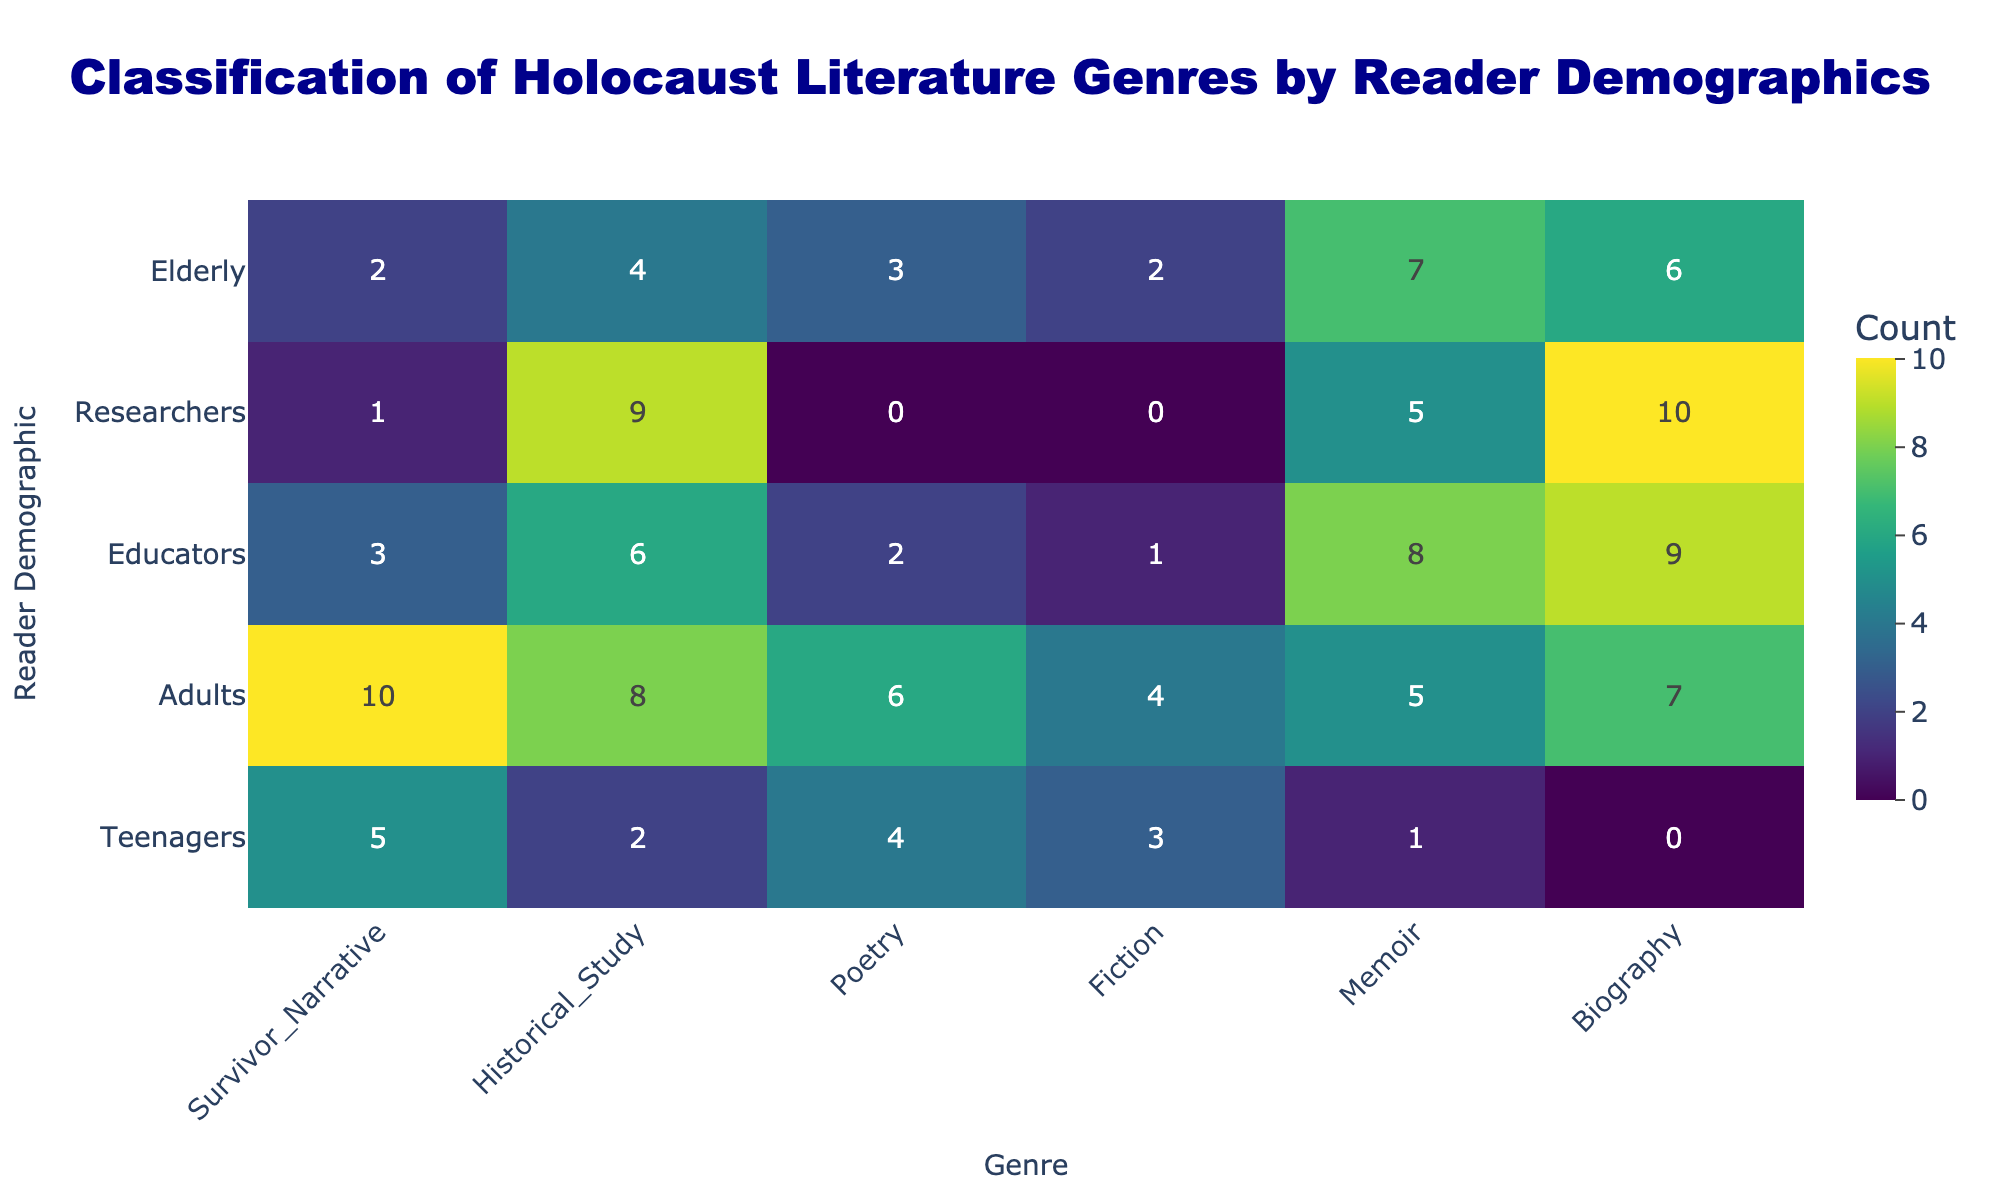What is the total count of "Fiction" genre read by "Adults"? From the "Adults" row in the "Fiction" column, the count is 4.
Answer: 4 What is the highest count of any genre among "Teenagers"? The counts for "Teenagers" are: Survivor Narrative (5), Historical Study (2), Poetry (4), Fiction (3), Memoir (1), Biography (0). The highest count is 5 for the Survivor Narrative.
Answer: 5 Is the count for "Biography" among "Researchers" greater than 5? The count for "Biography" in the "Researchers" row is 10, which is greater than 5.
Answer: Yes What is the average count of the "Historical Study" genre across all demographics? The counts for "Historical Study" across demographics are: 2 (Teenagers), 8 (Adults), 6 (Educators), 9 (Researchers), 4 (Elderly). The sum is (2 + 8 + 6 + 9 + 4) = 29. There are 5 demographics, so the average is 29/5 = 5.8.
Answer: 5.8 Which demographic read the most "Poetry"? The counts for "Poetry" across demographics are: 4 (Teenagers), 6 (Adults), 2 (Educators), 0 (Researchers), 3 (Elderly). The highest count is 6 for the Adults demographic.
Answer: Adults What is the difference between the counts of "Survivor Narrative" for "Adults" and "Teenagers"? The count of "Survivor Narrative" for "Adults" is 10, and for "Teenagers," it is 5. The difference is 10 - 5 = 5.
Answer: 5 Did the "Elderly" demographic read more "Memoir" than "Historical Study"? The count for "Memoir" among "Elderly" is 7, and for "Historical Study," it is 4. Since 7 is greater than 4, the statement is true.
Answer: Yes What is the total count of "Survivor Narrative" across all demographics? The counts for "Survivor Narrative" are: 5 (Teenagers), 10 (Adults), 3 (Educators), 1 (Researchers), 2 (Elderly). The total is (5 + 10 + 3 + 1 + 2) = 21.
Answer: 21 Which genre has the lowest count among "Researchers"? The counts for "Researchers" are: Survivor Narrative (1), Historical Study (9), Poetry (0), Fiction (0), Memoir (5), Biography (10). The lowest count is 0 for both Poetry and Fiction.
Answer: Poetry and Fiction What genre did "Educators" read the most? The counts for "Educators" are: Survivor Narrative (3), Historical Study (6), Poetry (2), Fiction (1), Memoir (8), Biography (9). The highest count is 9 for Biography.
Answer: Biography 